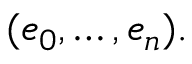<formula> <loc_0><loc_0><loc_500><loc_500>( e _ { 0 } , \dots , e _ { n } ) .</formula> 